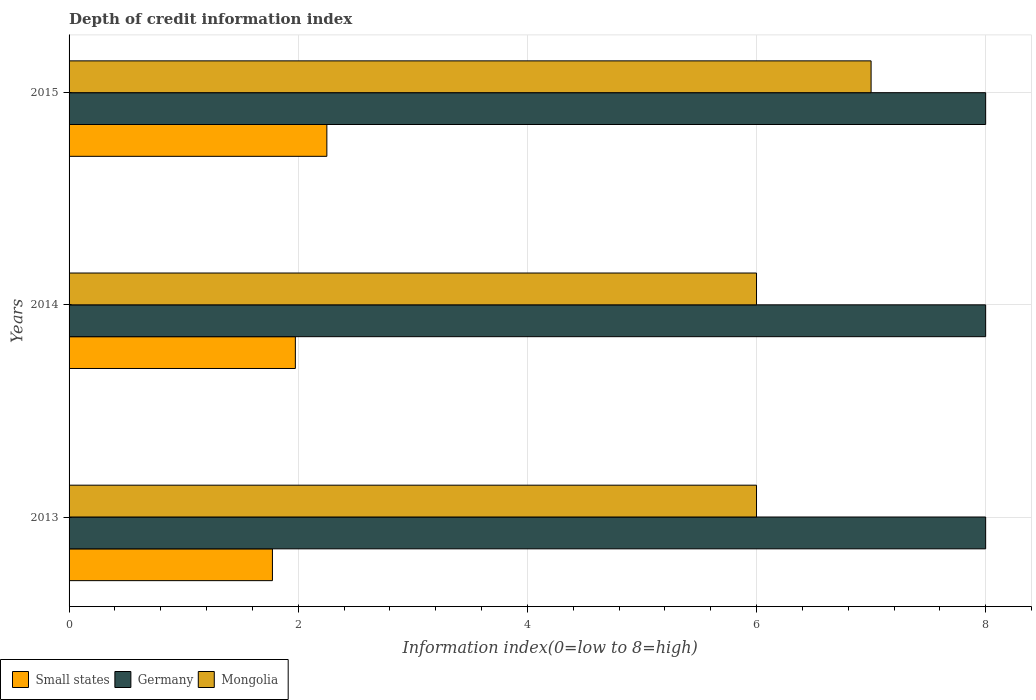How many different coloured bars are there?
Provide a succinct answer. 3. Are the number of bars on each tick of the Y-axis equal?
Ensure brevity in your answer.  Yes. How many bars are there on the 3rd tick from the top?
Your response must be concise. 3. What is the information index in Mongolia in 2015?
Offer a very short reply. 7. Across all years, what is the maximum information index in Mongolia?
Offer a terse response. 7. Across all years, what is the minimum information index in Mongolia?
Your answer should be very brief. 6. In which year was the information index in Mongolia maximum?
Your answer should be compact. 2015. What is the total information index in Mongolia in the graph?
Provide a short and direct response. 19. What is the difference between the information index in Germany in 2014 and that in 2015?
Provide a succinct answer. 0. What is the difference between the information index in Germany in 2013 and the information index in Small states in 2015?
Your answer should be very brief. 5.75. What is the average information index in Mongolia per year?
Ensure brevity in your answer.  6.33. In the year 2013, what is the difference between the information index in Mongolia and information index in Small states?
Provide a short and direct response. 4.22. In how many years, is the information index in Mongolia greater than the average information index in Mongolia taken over all years?
Your answer should be very brief. 1. What does the 1st bar from the top in 2013 represents?
Your answer should be compact. Mongolia. What does the 1st bar from the bottom in 2013 represents?
Your answer should be compact. Small states. Is it the case that in every year, the sum of the information index in Mongolia and information index in Germany is greater than the information index in Small states?
Your answer should be compact. Yes. How many bars are there?
Offer a very short reply. 9. Are all the bars in the graph horizontal?
Offer a terse response. Yes. Does the graph contain any zero values?
Provide a succinct answer. No. Does the graph contain grids?
Your answer should be very brief. Yes. Where does the legend appear in the graph?
Your answer should be compact. Bottom left. How many legend labels are there?
Keep it short and to the point. 3. What is the title of the graph?
Your response must be concise. Depth of credit information index. What is the label or title of the X-axis?
Offer a terse response. Information index(0=low to 8=high). What is the Information index(0=low to 8=high) in Small states in 2013?
Your response must be concise. 1.77. What is the Information index(0=low to 8=high) in Germany in 2013?
Your answer should be very brief. 8. What is the Information index(0=low to 8=high) of Mongolia in 2013?
Offer a very short reply. 6. What is the Information index(0=low to 8=high) in Small states in 2014?
Your answer should be compact. 1.98. What is the Information index(0=low to 8=high) of Germany in 2014?
Give a very brief answer. 8. What is the Information index(0=low to 8=high) in Small states in 2015?
Provide a short and direct response. 2.25. Across all years, what is the maximum Information index(0=low to 8=high) of Small states?
Offer a very short reply. 2.25. Across all years, what is the maximum Information index(0=low to 8=high) of Mongolia?
Make the answer very short. 7. Across all years, what is the minimum Information index(0=low to 8=high) of Small states?
Your response must be concise. 1.77. Across all years, what is the minimum Information index(0=low to 8=high) of Germany?
Give a very brief answer. 8. Across all years, what is the minimum Information index(0=low to 8=high) of Mongolia?
Offer a terse response. 6. What is the total Information index(0=low to 8=high) of Germany in the graph?
Offer a terse response. 24. What is the difference between the Information index(0=low to 8=high) of Small states in 2013 and that in 2014?
Keep it short and to the point. -0.2. What is the difference between the Information index(0=low to 8=high) of Small states in 2013 and that in 2015?
Offer a terse response. -0.47. What is the difference between the Information index(0=low to 8=high) of Germany in 2013 and that in 2015?
Give a very brief answer. 0. What is the difference between the Information index(0=low to 8=high) in Mongolia in 2013 and that in 2015?
Offer a very short reply. -1. What is the difference between the Information index(0=low to 8=high) in Small states in 2014 and that in 2015?
Make the answer very short. -0.28. What is the difference between the Information index(0=low to 8=high) in Small states in 2013 and the Information index(0=low to 8=high) in Germany in 2014?
Your answer should be very brief. -6.22. What is the difference between the Information index(0=low to 8=high) of Small states in 2013 and the Information index(0=low to 8=high) of Mongolia in 2014?
Your answer should be very brief. -4.22. What is the difference between the Information index(0=low to 8=high) of Germany in 2013 and the Information index(0=low to 8=high) of Mongolia in 2014?
Offer a very short reply. 2. What is the difference between the Information index(0=low to 8=high) in Small states in 2013 and the Information index(0=low to 8=high) in Germany in 2015?
Make the answer very short. -6.22. What is the difference between the Information index(0=low to 8=high) of Small states in 2013 and the Information index(0=low to 8=high) of Mongolia in 2015?
Ensure brevity in your answer.  -5.22. What is the difference between the Information index(0=low to 8=high) in Germany in 2013 and the Information index(0=low to 8=high) in Mongolia in 2015?
Offer a terse response. 1. What is the difference between the Information index(0=low to 8=high) of Small states in 2014 and the Information index(0=low to 8=high) of Germany in 2015?
Offer a terse response. -6.03. What is the difference between the Information index(0=low to 8=high) in Small states in 2014 and the Information index(0=low to 8=high) in Mongolia in 2015?
Offer a very short reply. -5.03. What is the difference between the Information index(0=low to 8=high) in Germany in 2014 and the Information index(0=low to 8=high) in Mongolia in 2015?
Your response must be concise. 1. What is the average Information index(0=low to 8=high) in Small states per year?
Offer a very short reply. 2. What is the average Information index(0=low to 8=high) in Mongolia per year?
Give a very brief answer. 6.33. In the year 2013, what is the difference between the Information index(0=low to 8=high) in Small states and Information index(0=low to 8=high) in Germany?
Offer a terse response. -6.22. In the year 2013, what is the difference between the Information index(0=low to 8=high) in Small states and Information index(0=low to 8=high) in Mongolia?
Ensure brevity in your answer.  -4.22. In the year 2013, what is the difference between the Information index(0=low to 8=high) in Germany and Information index(0=low to 8=high) in Mongolia?
Offer a very short reply. 2. In the year 2014, what is the difference between the Information index(0=low to 8=high) of Small states and Information index(0=low to 8=high) of Germany?
Offer a very short reply. -6.03. In the year 2014, what is the difference between the Information index(0=low to 8=high) of Small states and Information index(0=low to 8=high) of Mongolia?
Give a very brief answer. -4.03. In the year 2014, what is the difference between the Information index(0=low to 8=high) of Germany and Information index(0=low to 8=high) of Mongolia?
Provide a short and direct response. 2. In the year 2015, what is the difference between the Information index(0=low to 8=high) in Small states and Information index(0=low to 8=high) in Germany?
Give a very brief answer. -5.75. In the year 2015, what is the difference between the Information index(0=low to 8=high) of Small states and Information index(0=low to 8=high) of Mongolia?
Make the answer very short. -4.75. In the year 2015, what is the difference between the Information index(0=low to 8=high) in Germany and Information index(0=low to 8=high) in Mongolia?
Make the answer very short. 1. What is the ratio of the Information index(0=low to 8=high) in Small states in 2013 to that in 2014?
Make the answer very short. 0.9. What is the ratio of the Information index(0=low to 8=high) in Small states in 2013 to that in 2015?
Your response must be concise. 0.79. What is the ratio of the Information index(0=low to 8=high) of Small states in 2014 to that in 2015?
Ensure brevity in your answer.  0.88. What is the ratio of the Information index(0=low to 8=high) in Mongolia in 2014 to that in 2015?
Offer a terse response. 0.86. What is the difference between the highest and the second highest Information index(0=low to 8=high) in Small states?
Offer a very short reply. 0.28. What is the difference between the highest and the lowest Information index(0=low to 8=high) in Small states?
Your answer should be very brief. 0.47. What is the difference between the highest and the lowest Information index(0=low to 8=high) of Mongolia?
Give a very brief answer. 1. 